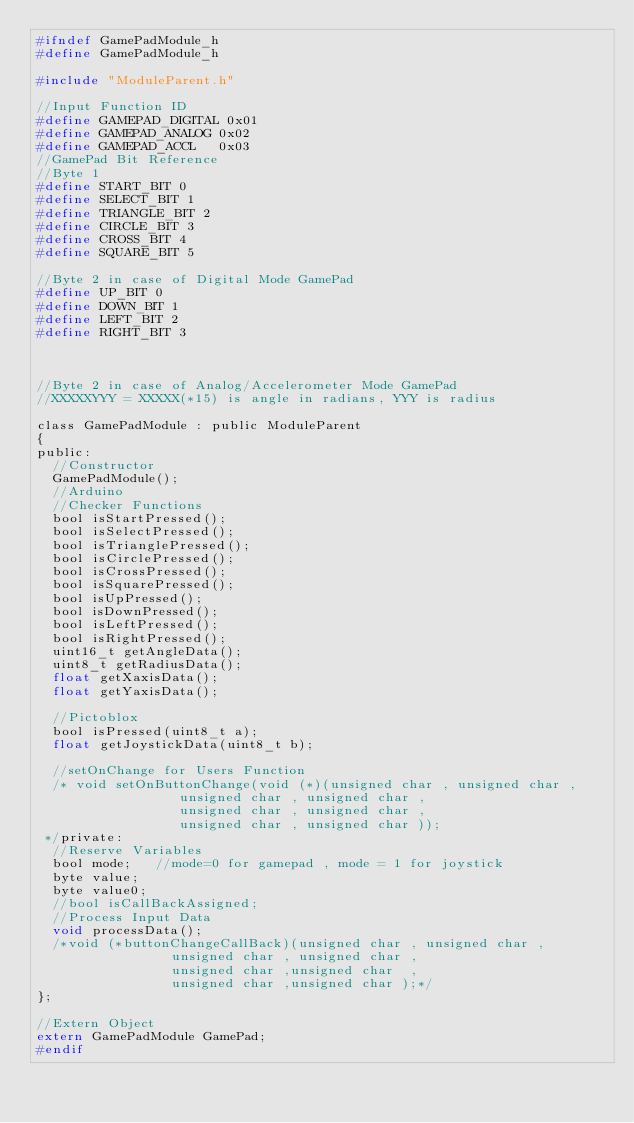<code> <loc_0><loc_0><loc_500><loc_500><_C_>#ifndef GamePadModule_h
#define GamePadModule_h

#include "ModuleParent.h"

//Input Function ID
#define GAMEPAD_DIGITAL 0x01
#define GAMEPAD_ANALOG 0x02
#define GAMEPAD_ACCL   0x03
//GamePad Bit Reference
//Byte 1
#define START_BIT 0
#define SELECT_BIT 1
#define TRIANGLE_BIT 2 
#define CIRCLE_BIT 3
#define CROSS_BIT 4
#define SQUARE_BIT 5

//Byte 2 in case of Digital Mode GamePad
#define UP_BIT 0
#define DOWN_BIT 1
#define LEFT_BIT 2
#define RIGHT_BIT 3



//Byte 2 in case of Analog/Accelerometer Mode GamePad
//XXXXXYYY = XXXXX(*15) is angle in radians, YYY is radius

class GamePadModule : public ModuleParent
{
public:
	//Constructor
	GamePadModule();
	//Arduino
	//Checker Functions
	bool isStartPressed();
	bool isSelectPressed();
	bool isTrianglePressed();
	bool isCirclePressed();
	bool isCrossPressed();
	bool isSquarePressed();
	bool isUpPressed();
	bool isDownPressed();
	bool isLeftPressed();
	bool isRightPressed();
	uint16_t getAngleData();
	uint8_t getRadiusData();
	float getXaxisData();
	float getYaxisData();
	
	//Pictoblox
	bool isPressed(uint8_t a);
	float getJoystickData(uint8_t b);
	
	//setOnChange for Users Function
	/* void setOnButtonChange(void (*)(unsigned char , unsigned char ,
									unsigned char , unsigned char ,
									unsigned char , unsigned char ,
									unsigned char , unsigned char ));
 */private:
	//Reserve Variables
	bool mode;   //mode=0 for gamepad , mode = 1 for joystick
	byte value;
	byte value0;
	//bool isCallBackAssigned;
	//Process Input Data  
	void processData();
	/*void (*buttonChangeCallBack)(unsigned char , unsigned char ,
								 unsigned char , unsigned char ,
								 unsigned char ,unsigned char  ,
								 unsigned char ,unsigned char );*/
};

//Extern Object
extern GamePadModule GamePad;
#endif </code> 